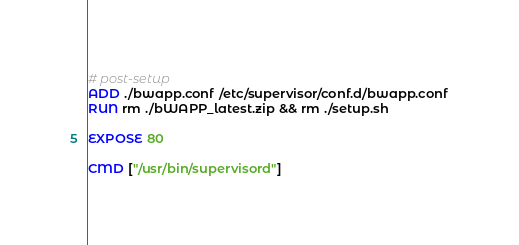<code> <loc_0><loc_0><loc_500><loc_500><_Dockerfile_>
# post-setup
ADD ./bwapp.conf /etc/supervisor/conf.d/bwapp.conf
RUN rm ./bWAPP_latest.zip && rm ./setup.sh

EXPOSE 80

CMD ["/usr/bin/supervisord"]
</code> 